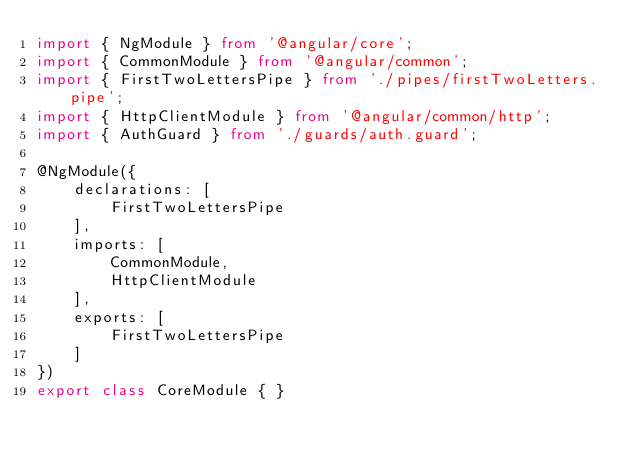<code> <loc_0><loc_0><loc_500><loc_500><_TypeScript_>import { NgModule } from '@angular/core';
import { CommonModule } from '@angular/common';
import { FirstTwoLettersPipe } from './pipes/firstTwoLetters.pipe';
import { HttpClientModule } from '@angular/common/http';
import { AuthGuard } from './guards/auth.guard';

@NgModule({
    declarations: [
        FirstTwoLettersPipe
    ],
    imports: [
        CommonModule,
        HttpClientModule
    ],
    exports: [
        FirstTwoLettersPipe
    ]
})
export class CoreModule { }
</code> 